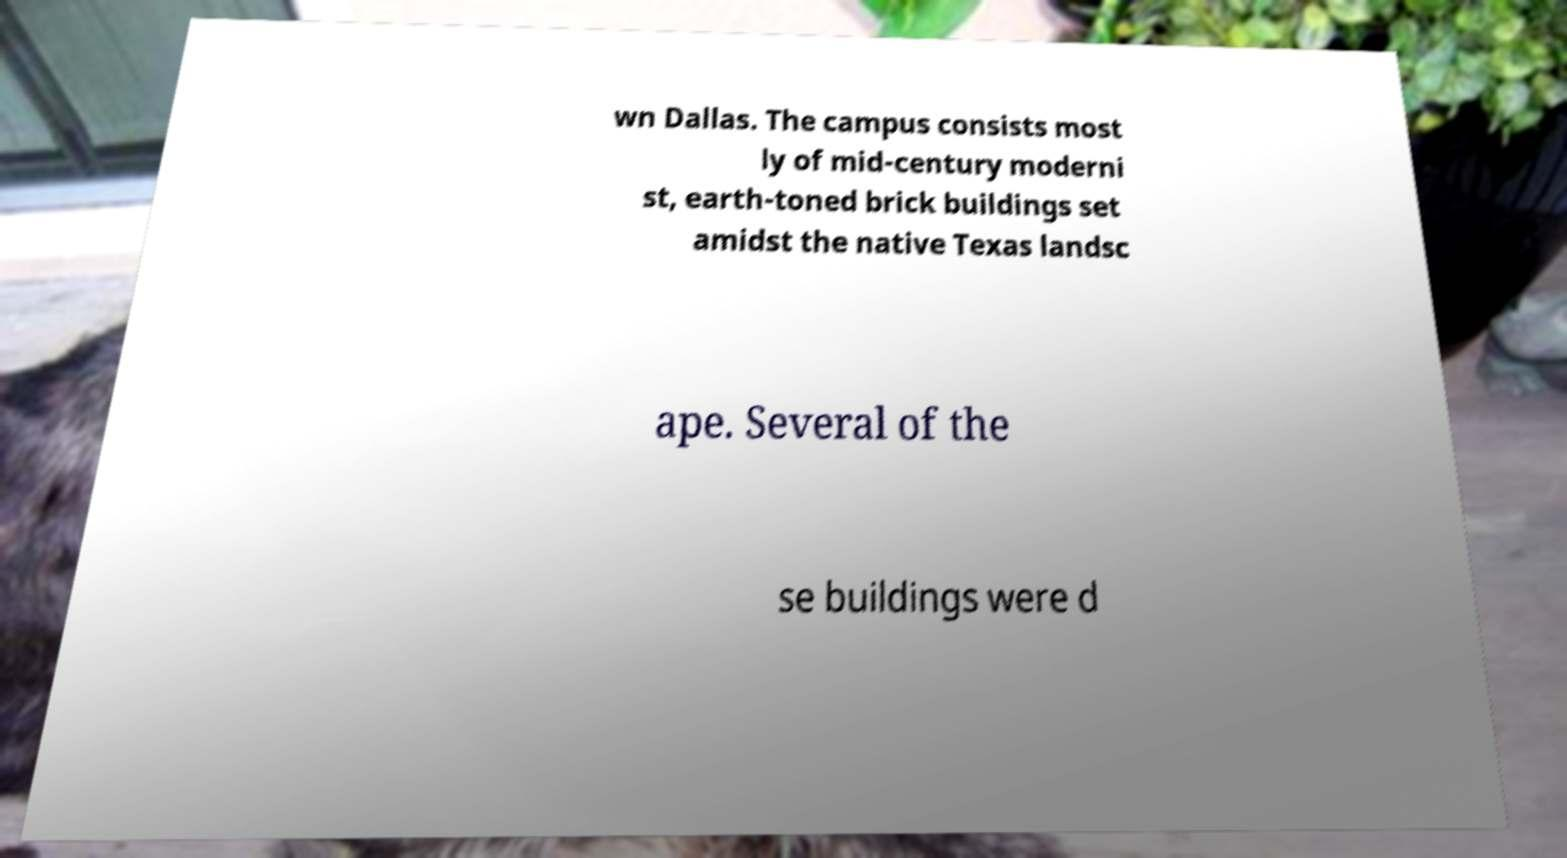There's text embedded in this image that I need extracted. Can you transcribe it verbatim? wn Dallas. The campus consists most ly of mid-century moderni st, earth-toned brick buildings set amidst the native Texas landsc ape. Several of the se buildings were d 